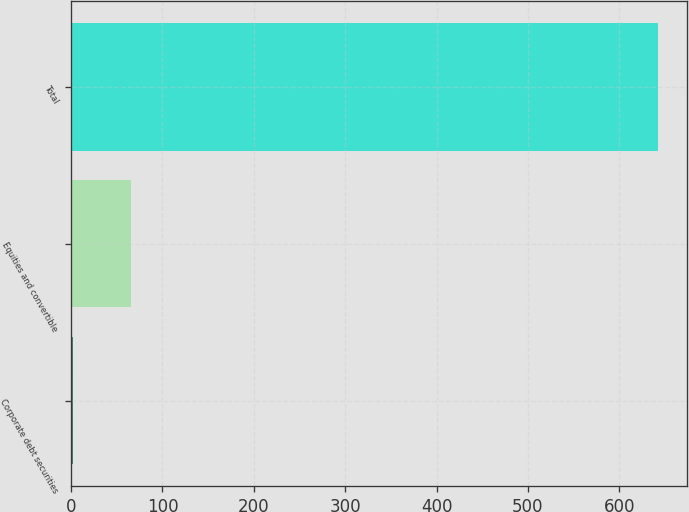Convert chart. <chart><loc_0><loc_0><loc_500><loc_500><bar_chart><fcel>Corporate debt securities<fcel>Equities and convertible<fcel>Total<nl><fcel>2<fcel>66<fcel>642<nl></chart> 